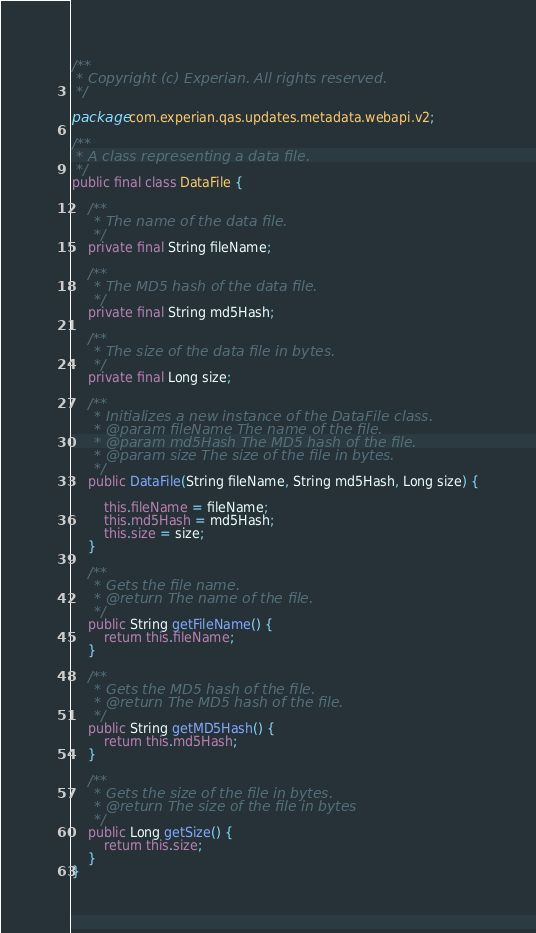<code> <loc_0><loc_0><loc_500><loc_500><_Java_>/**
 * Copyright (c) Experian. All rights reserved.
 */

package com.experian.qas.updates.metadata.webapi.v2;

/**
 * A class representing a data file.
 */
public final class DataFile {
    
    /**
     * The name of the data file.
     */
    private final String fileName;
    
    /**
     * The MD5 hash of the data file.
     */
    private final String md5Hash;
    
    /**
     * The size of the data file in bytes.
     */
    private final Long size;
    
    /**
     * Initializes a new instance of the DataFile class.
     * @param fileName The name of the file.
     * @param md5Hash The MD5 hash of the file.
     * @param size The size of the file in bytes.
     */
    public DataFile(String fileName, String md5Hash, Long size) {
        
        this.fileName = fileName;
        this.md5Hash = md5Hash;
        this.size = size;
    }
    
    /**
     * Gets the file name.
     * @return The name of the file.
     */
    public String getFileName() {
        return this.fileName;
    }
    
    /**
     * Gets the MD5 hash of the file.
     * @return The MD5 hash of the file.
     */
    public String getMD5Hash() {
        return this.md5Hash;
    }
    
    /**
     * Gets the size of the file in bytes.
     * @return The size of the file in bytes
     */
    public Long getSize() {
        return this.size;
    }
}
</code> 